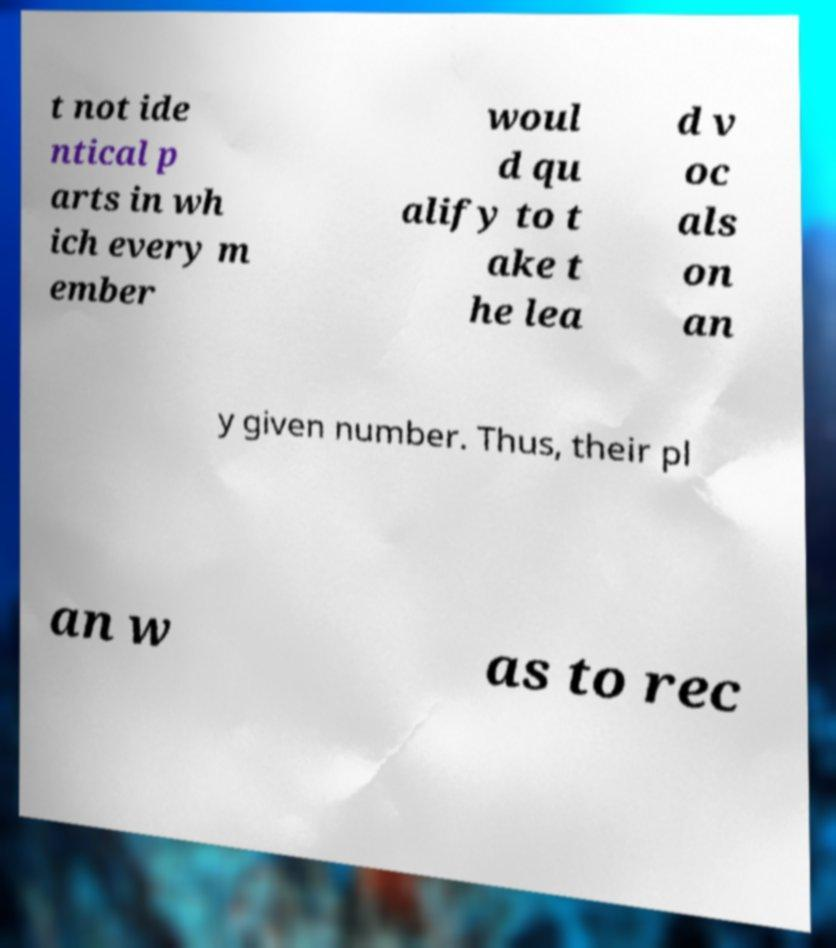Please read and relay the text visible in this image. What does it say? t not ide ntical p arts in wh ich every m ember woul d qu alify to t ake t he lea d v oc als on an y given number. Thus, their pl an w as to rec 